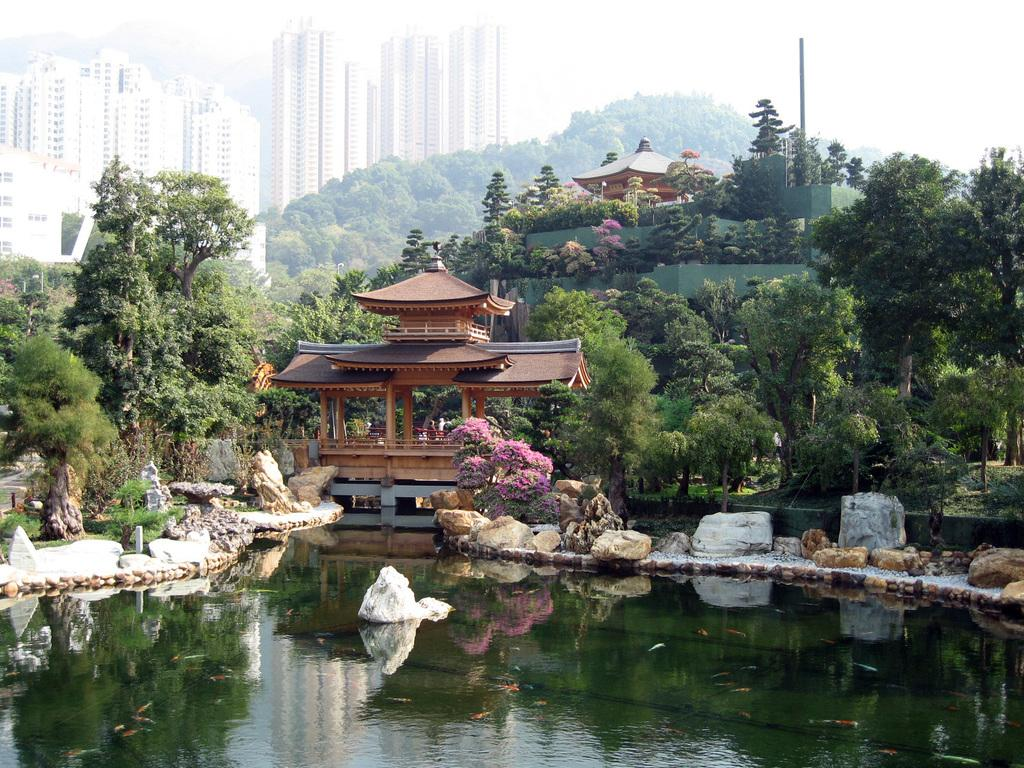What is the main feature in the image? There is a pond in the image. What can be seen on either side of the pond? There are rocks on either side of the pond. What is visible in the background of the image? There is an architecture, trees, and buildings in the background of the image. Can you see any jellyfish swimming in the pond in the image? There are no jellyfish present in the image; it features a pond with rocks on either side. 